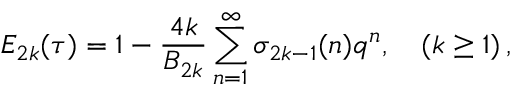Convert formula to latex. <formula><loc_0><loc_0><loc_500><loc_500>E _ { 2 k } ( \tau ) = 1 - \frac { 4 k } { B _ { 2 k } } \sum _ { n = 1 } ^ { \infty } \sigma _ { 2 k - 1 } ( n ) q ^ { n } , \quad ( k \geq 1 ) \, ,</formula> 